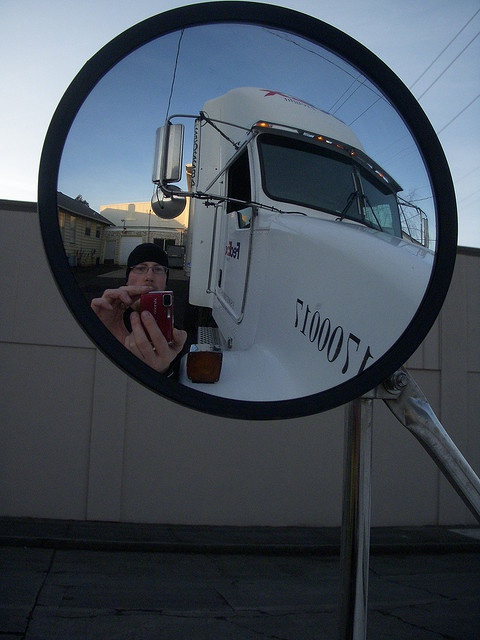Describe the objects in this image and their specific colors. I can see truck in darkgray, gray, and black tones and people in darkgray, black, and gray tones in this image. 